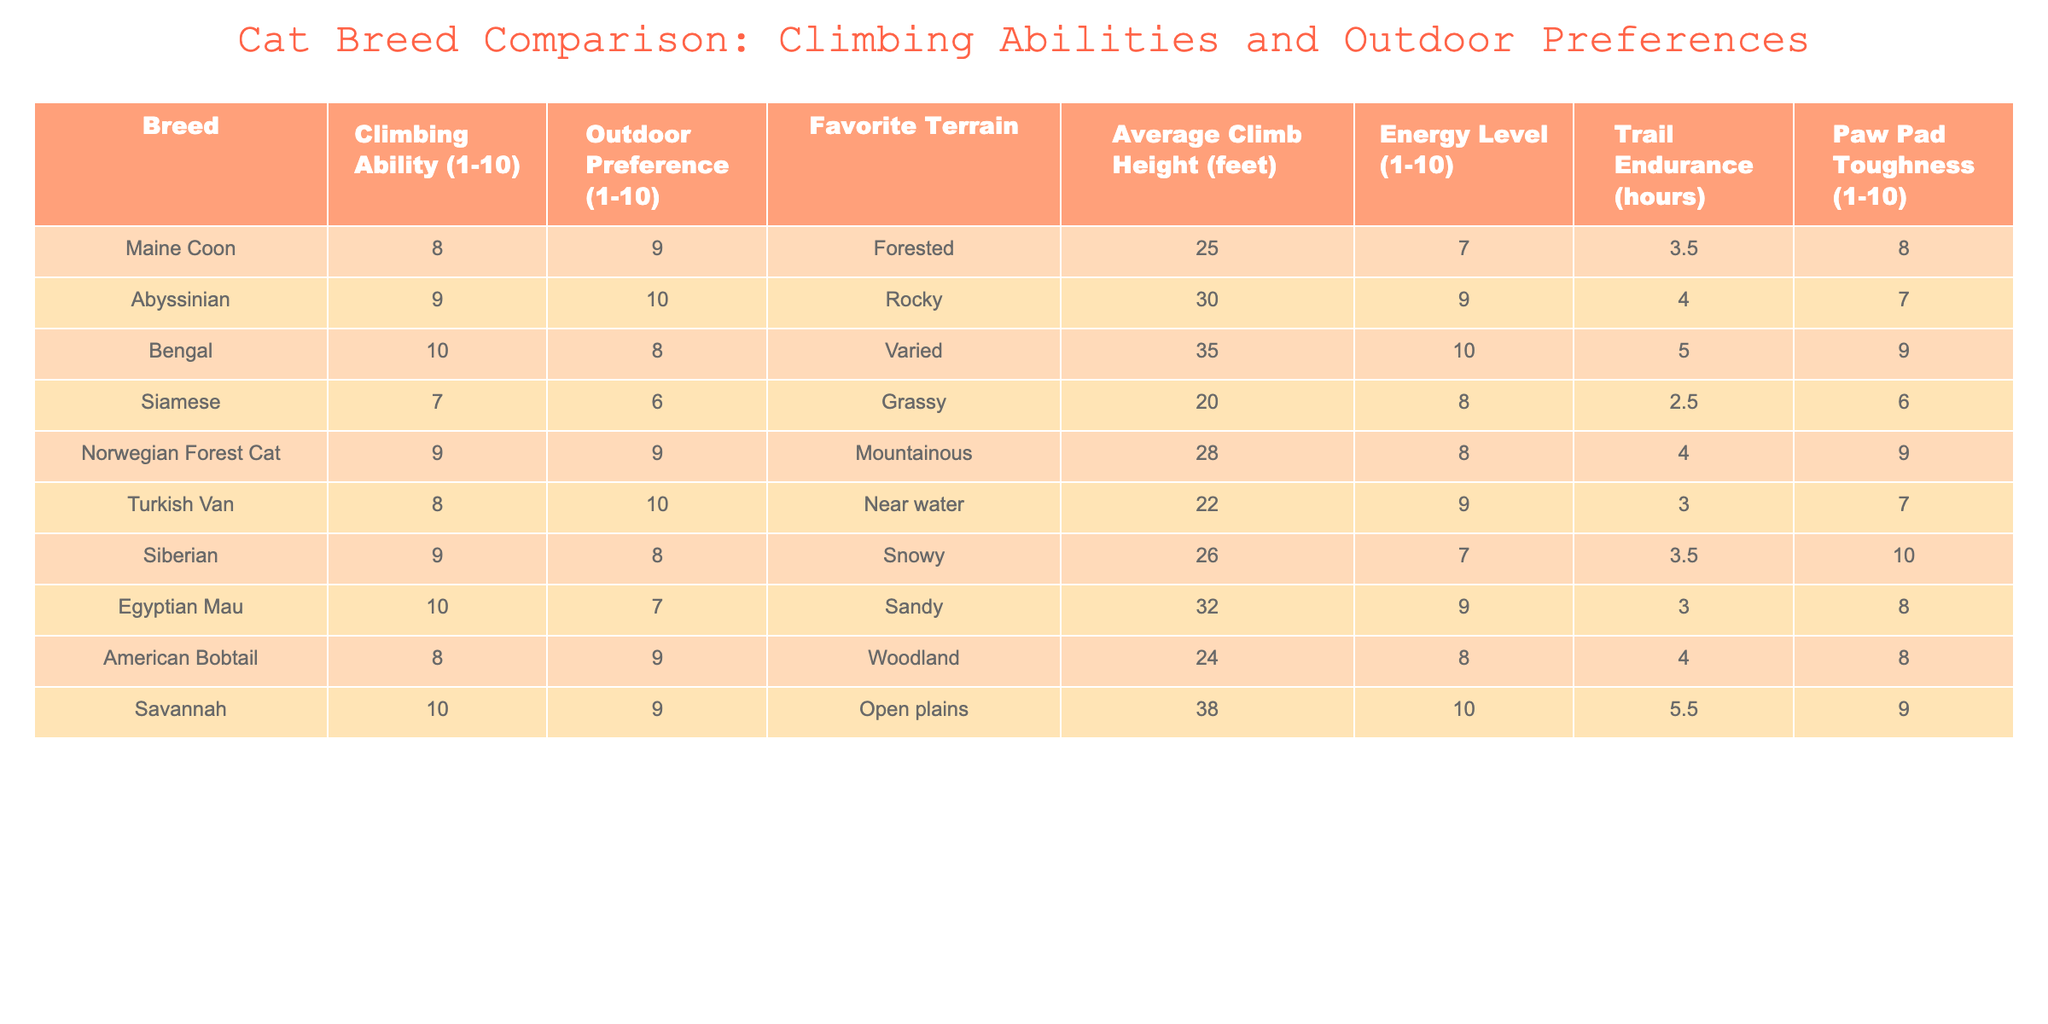What is the climbing ability of the Bengal cat? The table shows that the Bengal cat has a climbing ability rating of 10.
Answer: 10 Which cat breed has the highest average climb height? By looking at the "Average Climb Height" column, the Bengal cat has the highest value at 35 feet.
Answer: 35 feet Is the Abyssinian cat known for its energy level and outdoor preference? The table indicates that the Abyssinian has a high energy level of 9 and an outdoor preference of 10, indicating it is quite suited for outdoor activities.
Answer: Yes What is the average climbing ability of the Norwegian Forest Cat and the Siberian cat combined? The Norwegian Forest Cat has a climbing ability of 9 and the Siberian has a climbing ability of 9. The average is calculated as (9 + 9) / 2 = 9.
Answer: 9 Which breed prefers rocky terrain and has the highest energy level? The Abyssinian cat prefers rocky terrain and has an energy level of 9, which is the highest among the breeds listed.
Answer: Abyssinian What is the difference in trail endurance between the Bengal cat and the Siamese cat? The Bengal has a trail endurance of 5 hours and the Siamese has 2.5 hours. The difference is calculated as 5 - 2.5 = 2.5 hours.
Answer: 2.5 hours Does the Turkish Van have a higher climbing ability than the Maine Coon? The Turkish Van has a climbing ability of 8, while the Maine Coon also has a climbing ability of 8. They are equal.
Answer: No Which cat breeds have an outdoor preference of 9? The breeds with an outdoor preference of 9 are the Maine Coon, Norwegian Forest Cat, and American Bobtail.
Answer: Maine Coon, Norwegian Forest Cat, American Bobtail What is the median energy level of all the listed cat breeds? The energy levels of the breeds are: 7, 9, 10, 8, 8, 9, 7, 9, 10. Arranging these values gives: 7, 7, 8, 8, 9, 9, 9, 10, 10. The median (middle value) is 9, as there are an odd number of entries.
Answer: 9 